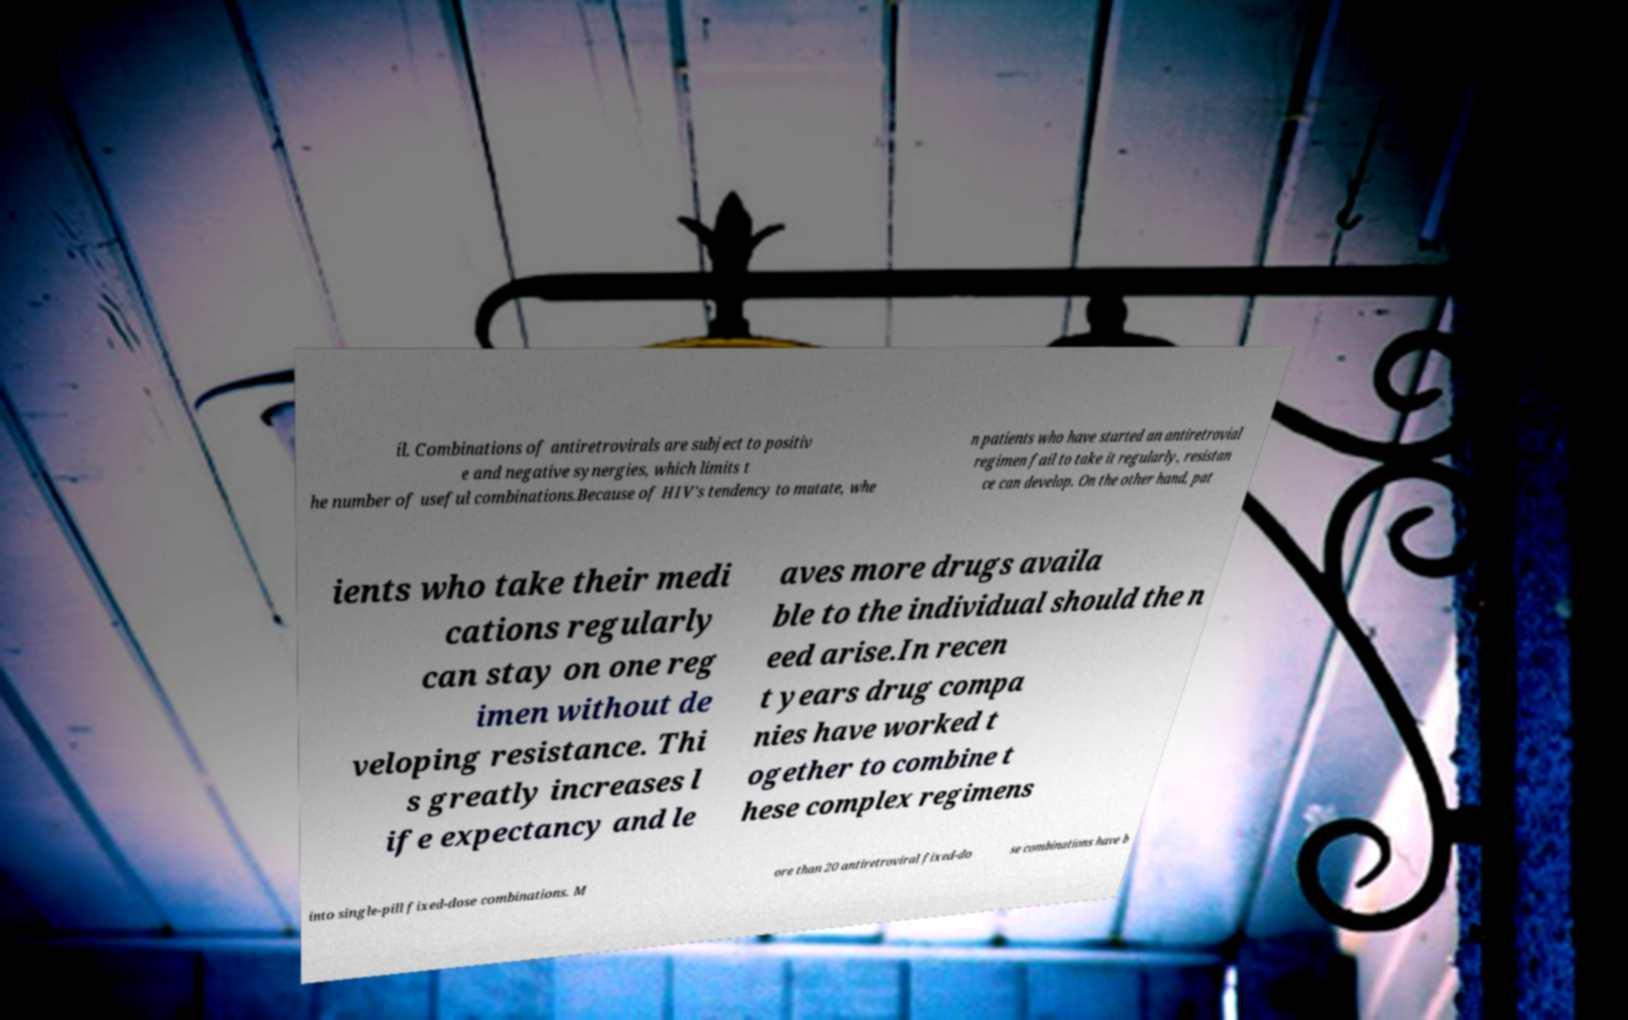Could you assist in decoding the text presented in this image and type it out clearly? il. Combinations of antiretrovirals are subject to positiv e and negative synergies, which limits t he number of useful combinations.Because of HIV's tendency to mutate, whe n patients who have started an antiretrovial regimen fail to take it regularly, resistan ce can develop. On the other hand, pat ients who take their medi cations regularly can stay on one reg imen without de veloping resistance. Thi s greatly increases l ife expectancy and le aves more drugs availa ble to the individual should the n eed arise.In recen t years drug compa nies have worked t ogether to combine t hese complex regimens into single-pill fixed-dose combinations. M ore than 20 antiretroviral fixed-do se combinations have b 